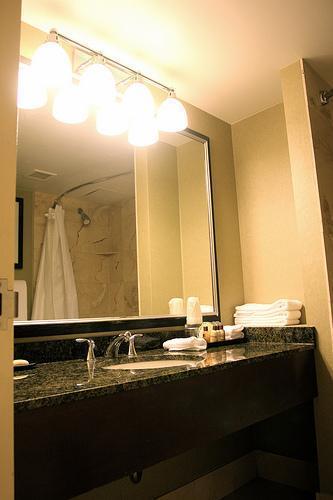How many sinks are there?
Give a very brief answer. 1. How many shower curtains are there?
Give a very brief answer. 1. How many toilets are in the photo?
Give a very brief answer. 0. How many shower heads are reflected in the mirror?
Give a very brief answer. 1. 